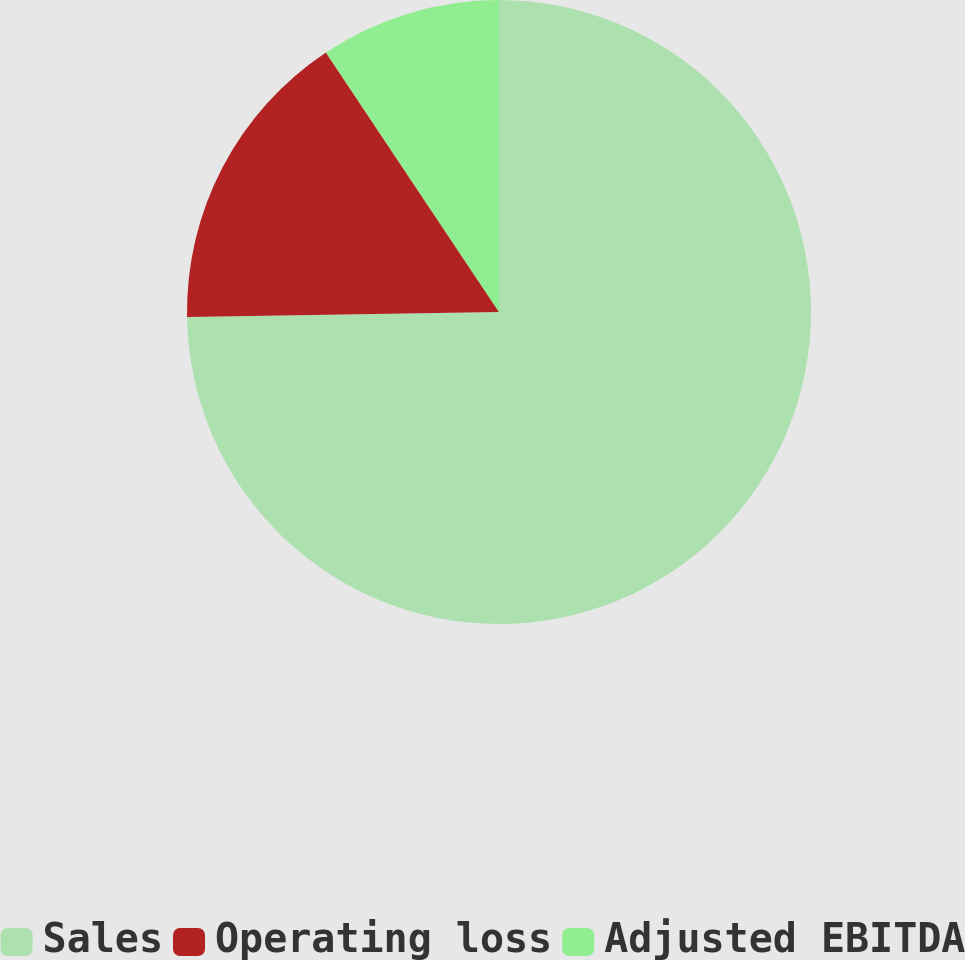Convert chart. <chart><loc_0><loc_0><loc_500><loc_500><pie_chart><fcel>Sales<fcel>Operating loss<fcel>Adjusted EBITDA<nl><fcel>74.75%<fcel>15.9%<fcel>9.36%<nl></chart> 